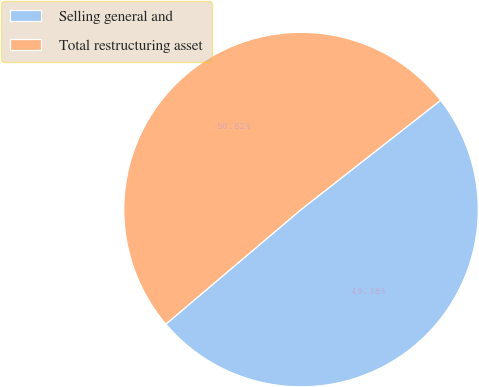Convert chart to OTSL. <chart><loc_0><loc_0><loc_500><loc_500><pie_chart><fcel>Selling general and<fcel>Total restructuring asset<nl><fcel>49.38%<fcel>50.62%<nl></chart> 